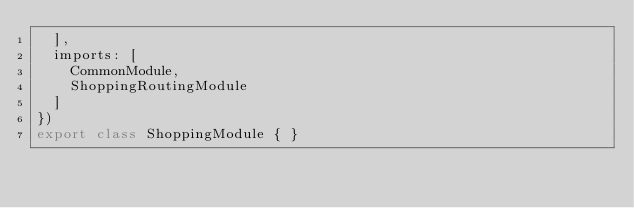<code> <loc_0><loc_0><loc_500><loc_500><_TypeScript_>  ],
  imports: [
    CommonModule,
    ShoppingRoutingModule
  ]
})
export class ShoppingModule { }
</code> 